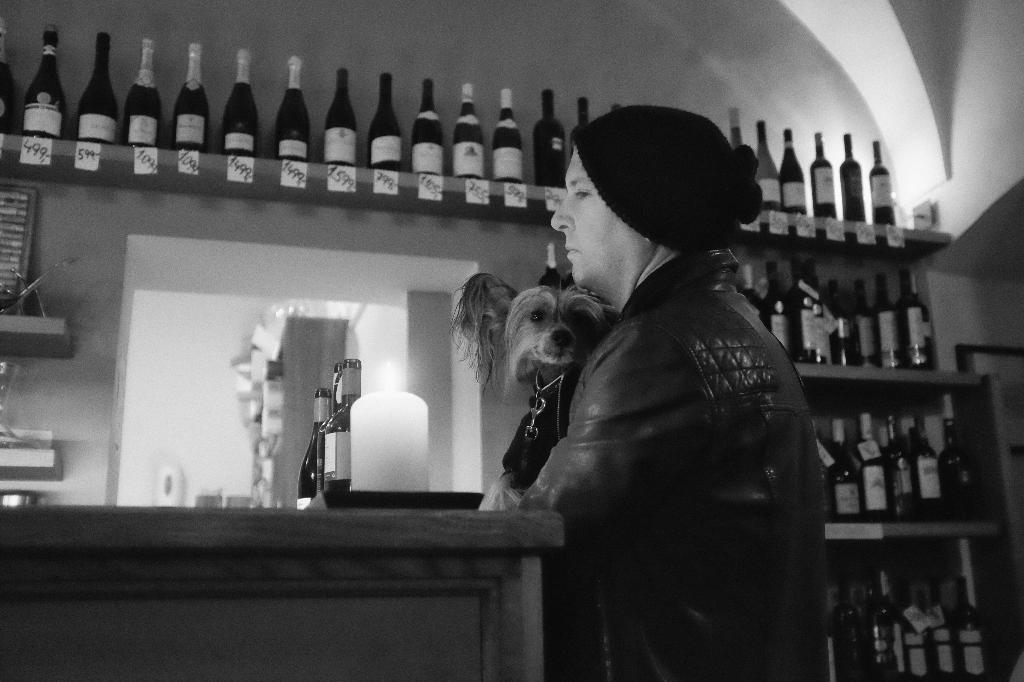Who is present in the image? There is a man in the image. What is the man holding in the image? The man is holding a dog. What objects can be seen on the wooden table in the image? There are wine bottles on the wooden table in the image. What type of crime is being committed in the image? There is no crime being committed in the image; it features a man holding a dog and wine bottles on a wooden table. 